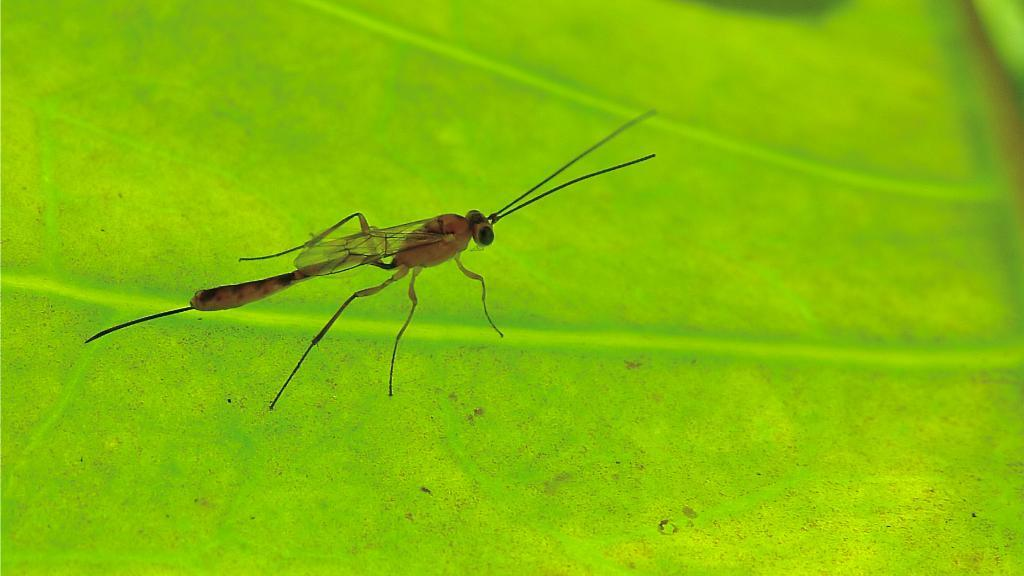What type of creature is in the image? There is an insect in the image. What is the insect resting on? The insect is on a green surface. How many plants are in harmony with the insect in the image? There is no mention of plants in the image, and the concept of harmony is not applicable to the image. 